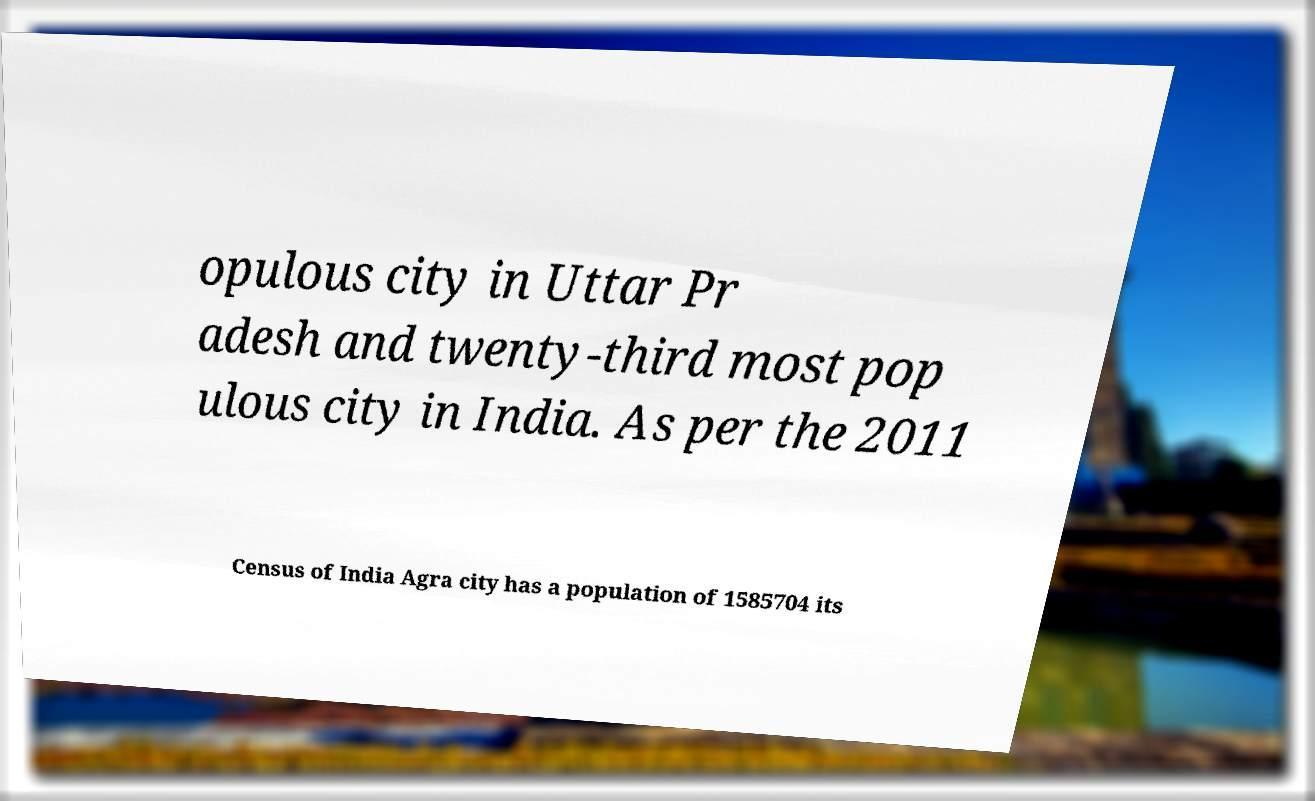Can you read and provide the text displayed in the image?This photo seems to have some interesting text. Can you extract and type it out for me? opulous city in Uttar Pr adesh and twenty-third most pop ulous city in India. As per the 2011 Census of India Agra city has a population of 1585704 its 